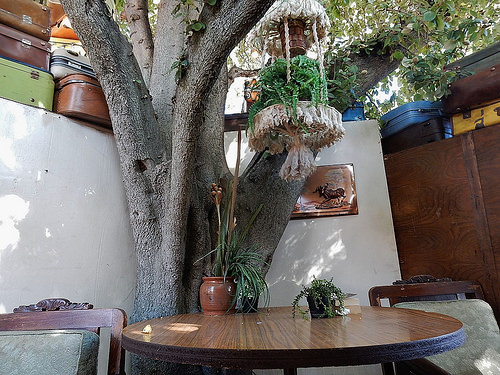<image>
Is the plaque above the potted plant? No. The plaque is not positioned above the potted plant. The vertical arrangement shows a different relationship. 